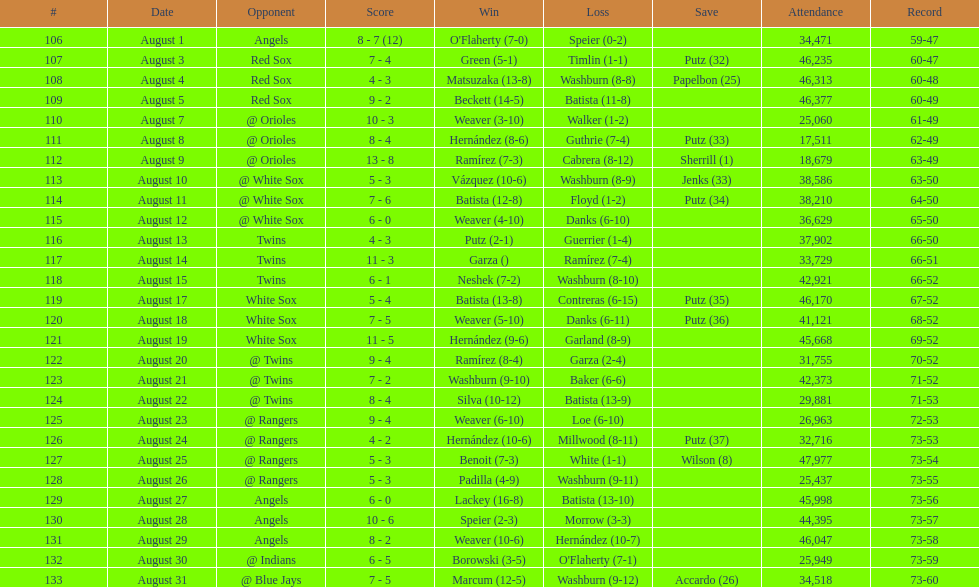In august 2007, how many games were played in total? 28. 